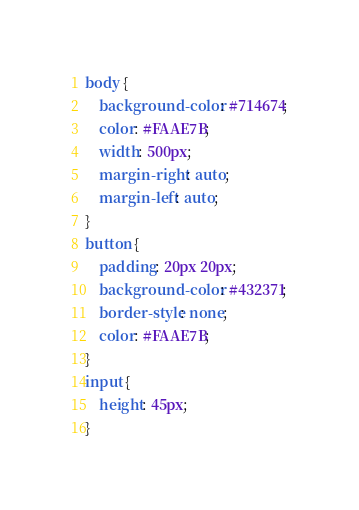Convert code to text. <code><loc_0><loc_0><loc_500><loc_500><_CSS_>body {
    background-color: #714674;
    color: #FAAE7B;
    width: 500px;
    margin-right: auto;
    margin-left: auto;
}
button {
    padding: 20px 20px;
    background-color: #432371;
    border-style: none;
    color: #FAAE7B;
}
input {
    height: 45px;
}
</code> 